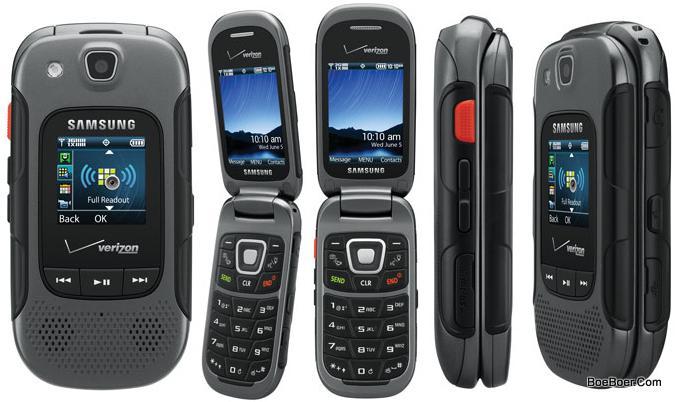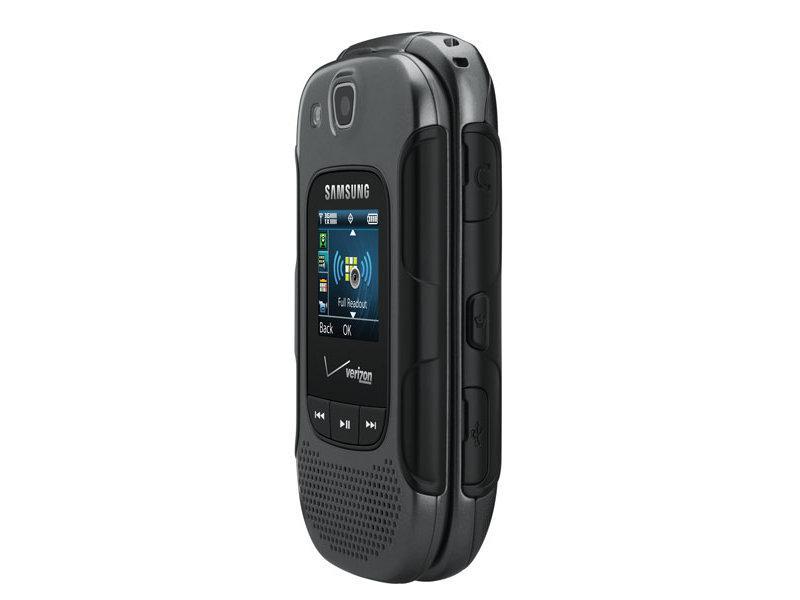The first image is the image on the left, the second image is the image on the right. Evaluate the accuracy of this statement regarding the images: "The left and right image contains the same number of flip phones.". Is it true? Answer yes or no. No. The first image is the image on the left, the second image is the image on the right. For the images displayed, is the sentence "Each image contains a single phone, and the phone in the right image has its top at least partially flipped open." factually correct? Answer yes or no. No. 